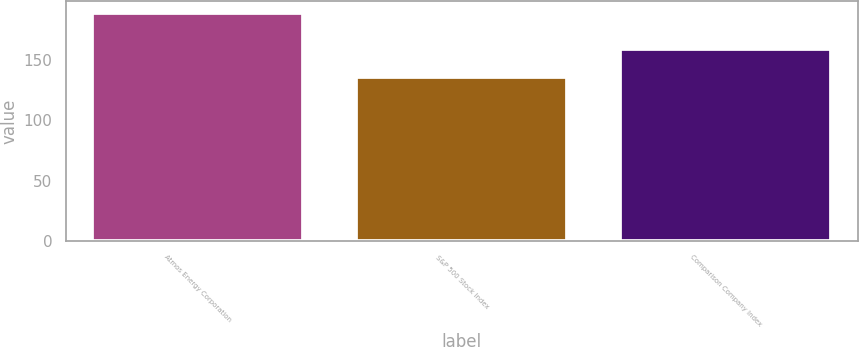Convert chart. <chart><loc_0><loc_0><loc_500><loc_500><bar_chart><fcel>Atmos Energy Corporation<fcel>S&P 500 Stock Index<fcel>Comparison Company Index<nl><fcel>189.56<fcel>136.07<fcel>159.21<nl></chart> 